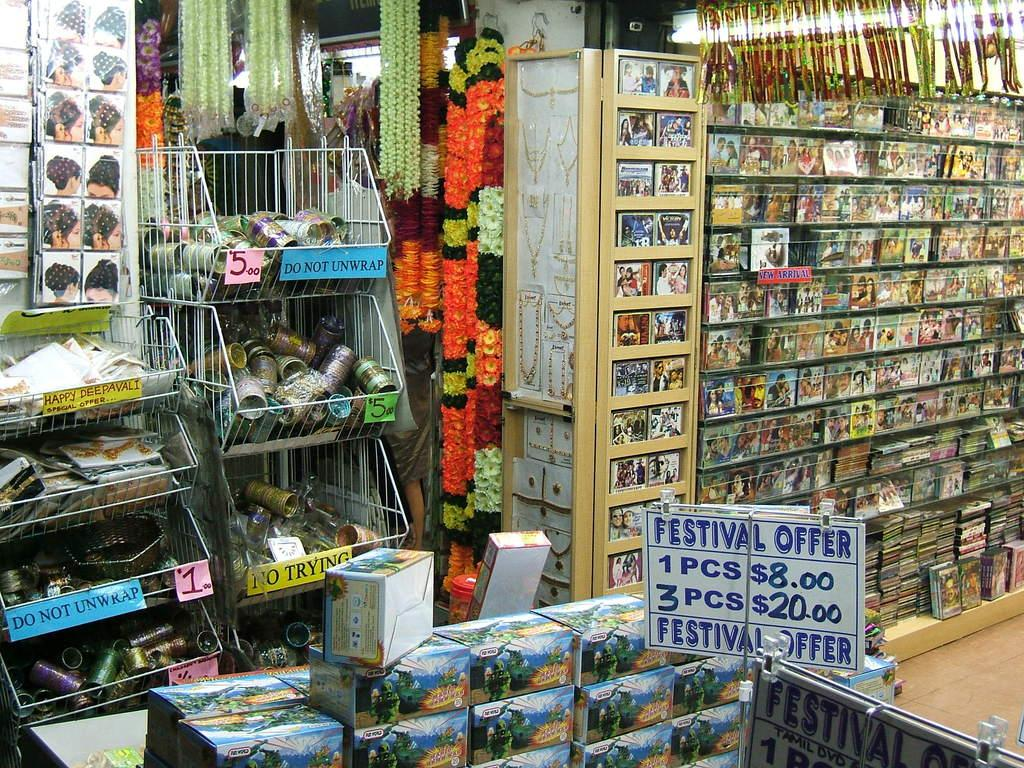<image>
Write a terse but informative summary of the picture. Store front with a sign that says one piece costs $8.00. 